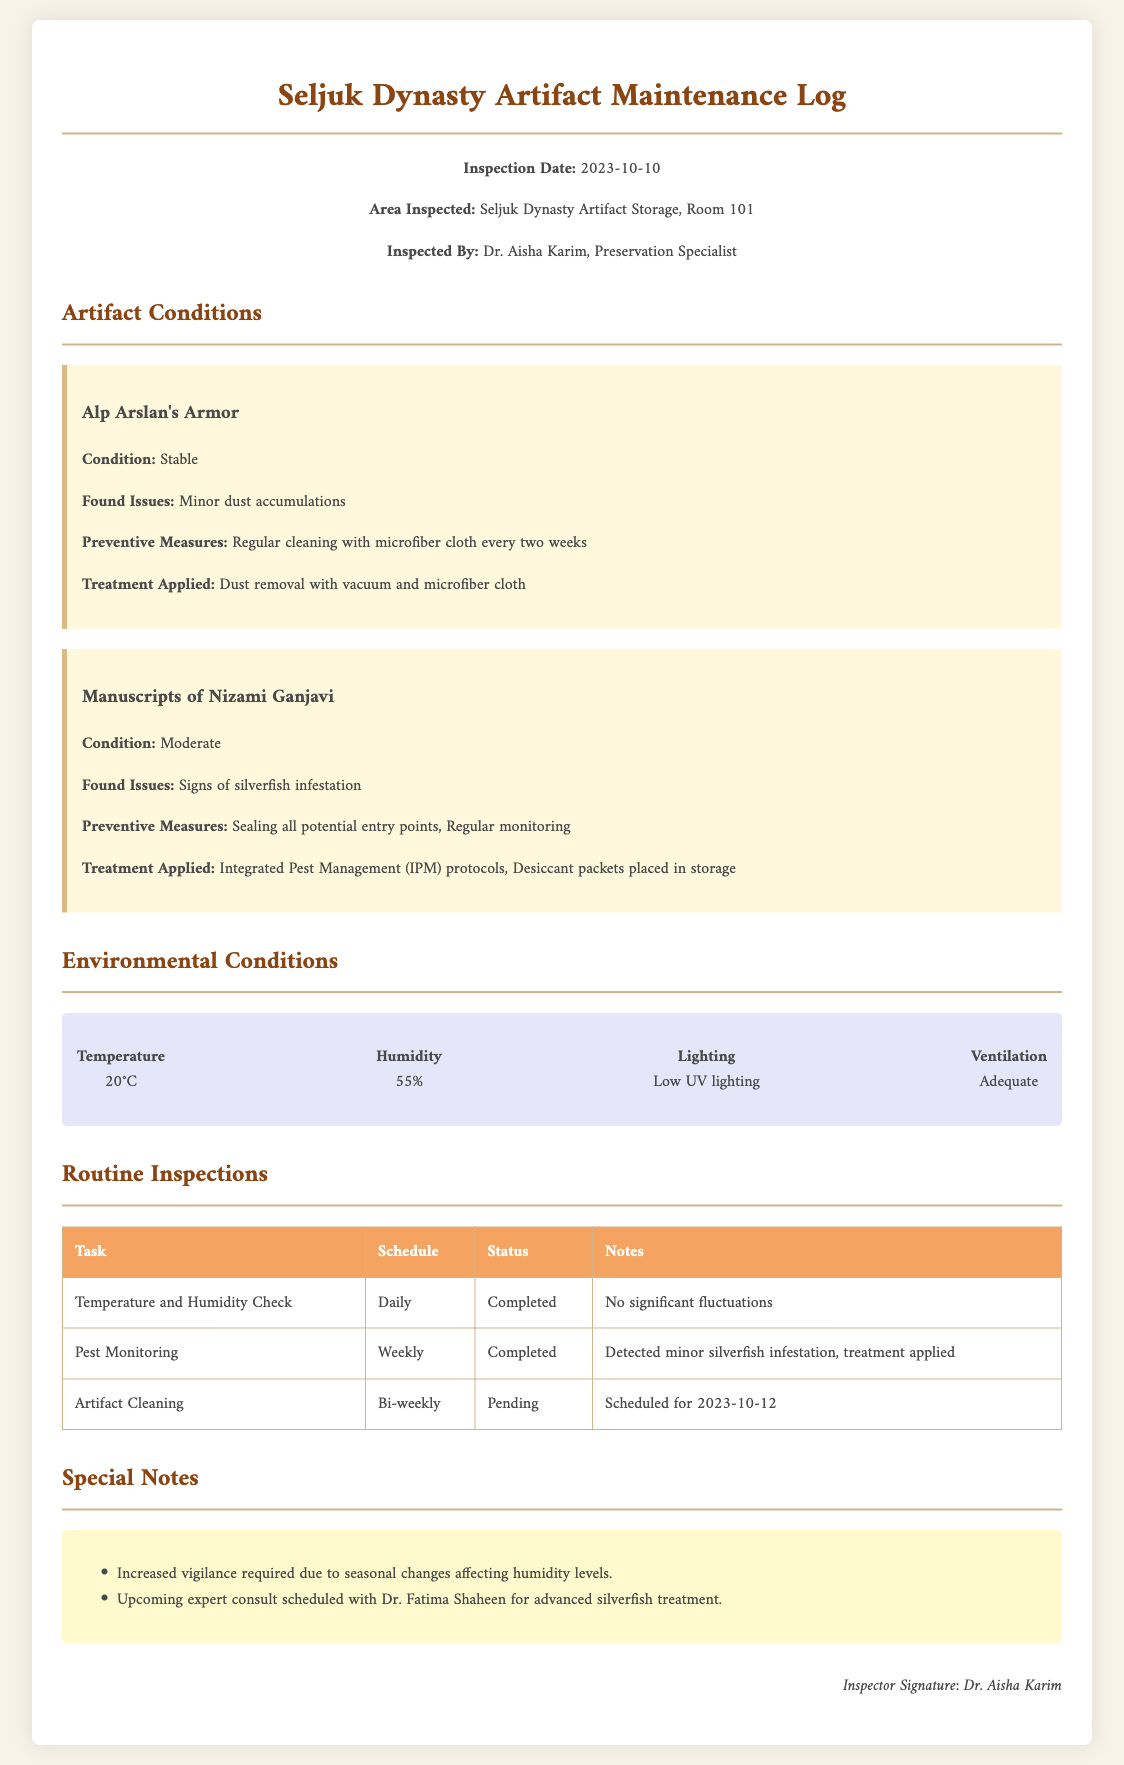What is the inspection date? The inspection date is explicitly mentioned at the beginning of the document.
Answer: 2023-10-10 Who inspected the artifact storage area? The inspector's name is provided in the header section of the document.
Answer: Dr. Aisha Karim What artifacts were inspected? The names of the artifacts are listed under the artifact conditions section.
Answer: Alp Arslan's Armor, Manuscripts of Nizami Ganjavi What treatment was applied to the Manuscripts of Nizami Ganjavi? The document specifies the treatment applied to this artifact under the artifact conditions section.
Answer: Integrated Pest Management (IPM) protocols, Desiccant packets placed in storage What is the humidity level recorded during the inspection? The humidity level is indicated in the environmental conditions section of the document.
Answer: 55% What upcoming task is scheduled on 2023-10-12? The routine inspections table outlines tasks and their schedules.
Answer: Artifact Cleaning What was found as an issue with Alp Arslan's Armor? The document lists specific issues found with each artifact.
Answer: Minor dust accumulations What special note indicates an upcoming consult? The special notes section highlights consultations and concerns.
Answer: Upcoming expert consult scheduled with Dr. Fatima Shaheen for advanced silverfish treatment 